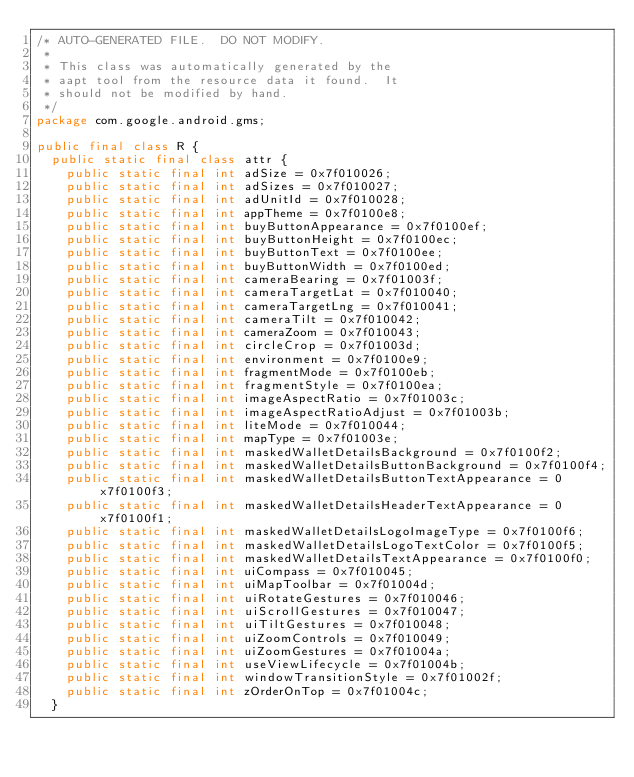<code> <loc_0><loc_0><loc_500><loc_500><_Java_>/* AUTO-GENERATED FILE.  DO NOT MODIFY.
 *
 * This class was automatically generated by the
 * aapt tool from the resource data it found.  It
 * should not be modified by hand.
 */
package com.google.android.gms;

public final class R {
	public static final class attr {
		public static final int adSize = 0x7f010026;
		public static final int adSizes = 0x7f010027;
		public static final int adUnitId = 0x7f010028;
		public static final int appTheme = 0x7f0100e8;
		public static final int buyButtonAppearance = 0x7f0100ef;
		public static final int buyButtonHeight = 0x7f0100ec;
		public static final int buyButtonText = 0x7f0100ee;
		public static final int buyButtonWidth = 0x7f0100ed;
		public static final int cameraBearing = 0x7f01003f;
		public static final int cameraTargetLat = 0x7f010040;
		public static final int cameraTargetLng = 0x7f010041;
		public static final int cameraTilt = 0x7f010042;
		public static final int cameraZoom = 0x7f010043;
		public static final int circleCrop = 0x7f01003d;
		public static final int environment = 0x7f0100e9;
		public static final int fragmentMode = 0x7f0100eb;
		public static final int fragmentStyle = 0x7f0100ea;
		public static final int imageAspectRatio = 0x7f01003c;
		public static final int imageAspectRatioAdjust = 0x7f01003b;
		public static final int liteMode = 0x7f010044;
		public static final int mapType = 0x7f01003e;
		public static final int maskedWalletDetailsBackground = 0x7f0100f2;
		public static final int maskedWalletDetailsButtonBackground = 0x7f0100f4;
		public static final int maskedWalletDetailsButtonTextAppearance = 0x7f0100f3;
		public static final int maskedWalletDetailsHeaderTextAppearance = 0x7f0100f1;
		public static final int maskedWalletDetailsLogoImageType = 0x7f0100f6;
		public static final int maskedWalletDetailsLogoTextColor = 0x7f0100f5;
		public static final int maskedWalletDetailsTextAppearance = 0x7f0100f0;
		public static final int uiCompass = 0x7f010045;
		public static final int uiMapToolbar = 0x7f01004d;
		public static final int uiRotateGestures = 0x7f010046;
		public static final int uiScrollGestures = 0x7f010047;
		public static final int uiTiltGestures = 0x7f010048;
		public static final int uiZoomControls = 0x7f010049;
		public static final int uiZoomGestures = 0x7f01004a;
		public static final int useViewLifecycle = 0x7f01004b;
		public static final int windowTransitionStyle = 0x7f01002f;
		public static final int zOrderOnTop = 0x7f01004c;
	}</code> 